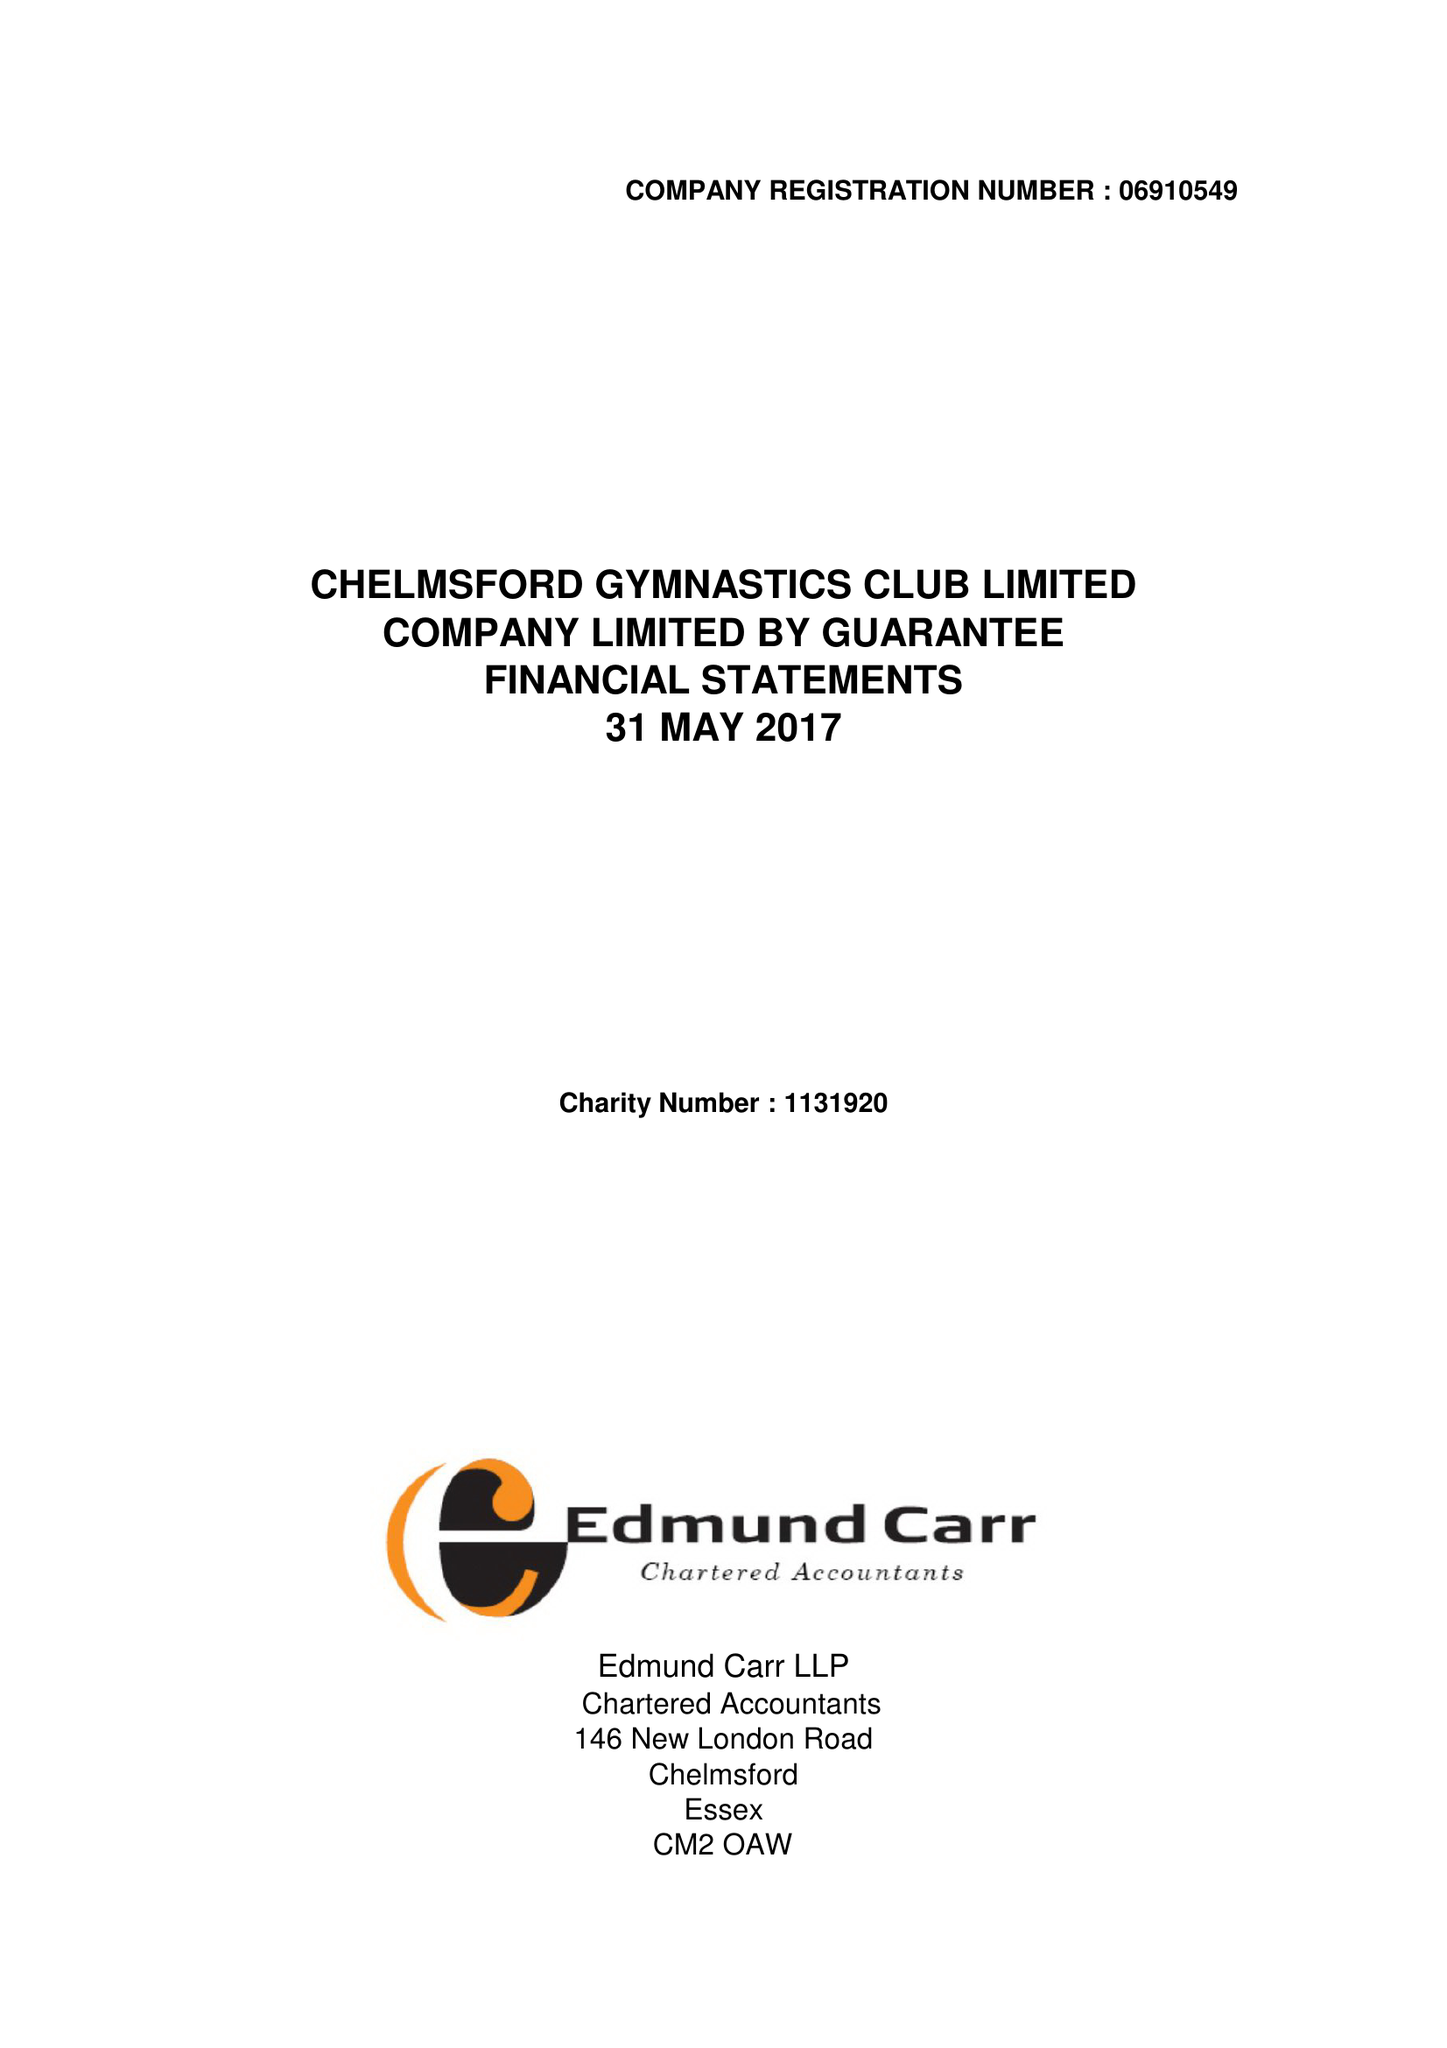What is the value for the address__postcode?
Answer the question using a single word or phrase. CM2 6BX 